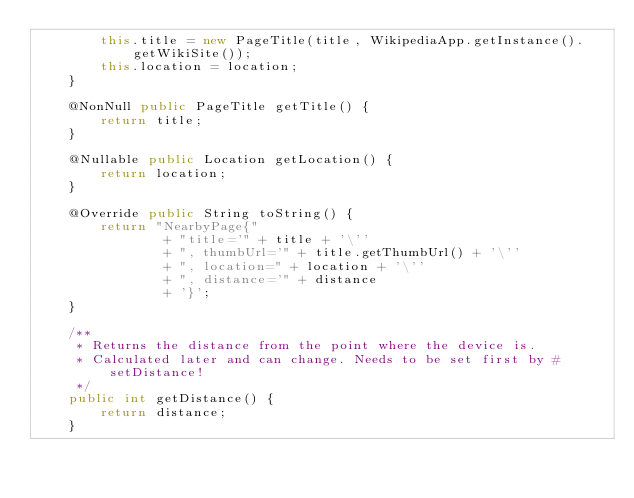Convert code to text. <code><loc_0><loc_0><loc_500><loc_500><_Java_>        this.title = new PageTitle(title, WikipediaApp.getInstance().getWikiSite());
        this.location = location;
    }

    @NonNull public PageTitle getTitle() {
        return title;
    }

    @Nullable public Location getLocation() {
        return location;
    }

    @Override public String toString() {
        return "NearbyPage{"
                + "title='" + title + '\''
                + ", thumbUrl='" + title.getThumbUrl() + '\''
                + ", location=" + location + '\''
                + ", distance='" + distance
                + '}';
    }

    /**
     * Returns the distance from the point where the device is.
     * Calculated later and can change. Needs to be set first by #setDistance!
     */
    public int getDistance() {
        return distance;
    }
</code> 